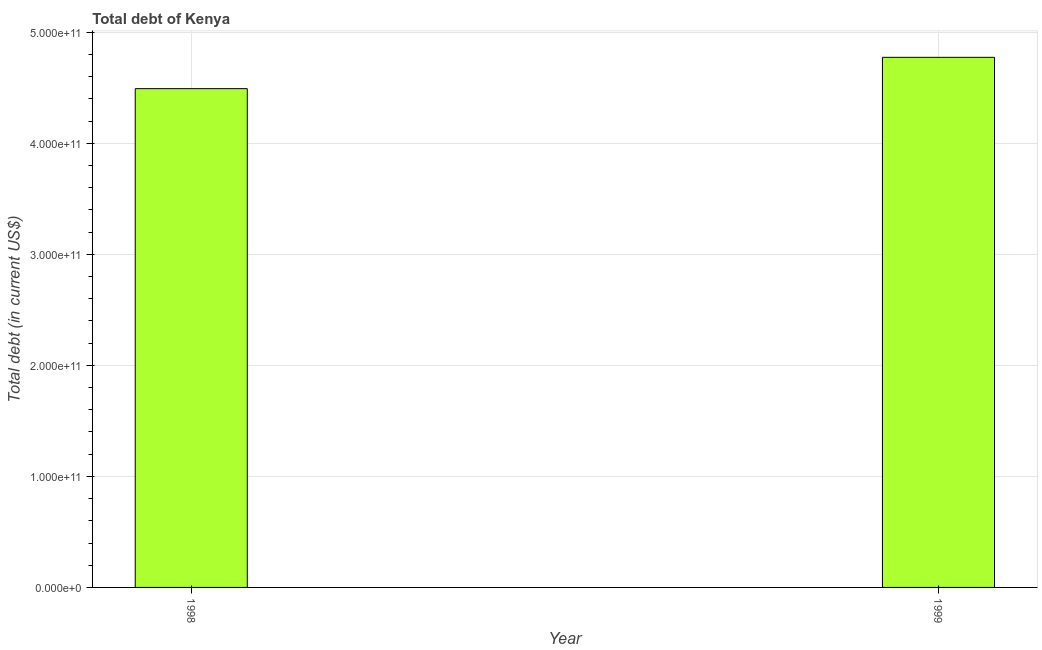Does the graph contain any zero values?
Your answer should be compact. No. Does the graph contain grids?
Make the answer very short. Yes. What is the title of the graph?
Offer a terse response. Total debt of Kenya. What is the label or title of the X-axis?
Keep it short and to the point. Year. What is the label or title of the Y-axis?
Provide a short and direct response. Total debt (in current US$). What is the total debt in 1998?
Offer a very short reply. 4.49e+11. Across all years, what is the maximum total debt?
Offer a terse response. 4.77e+11. Across all years, what is the minimum total debt?
Offer a terse response. 4.49e+11. In which year was the total debt minimum?
Make the answer very short. 1998. What is the sum of the total debt?
Offer a very short reply. 9.27e+11. What is the difference between the total debt in 1998 and 1999?
Your response must be concise. -2.82e+1. What is the average total debt per year?
Ensure brevity in your answer.  4.63e+11. What is the median total debt?
Offer a very short reply. 4.63e+11. What is the ratio of the total debt in 1998 to that in 1999?
Offer a terse response. 0.94. Are all the bars in the graph horizontal?
Offer a terse response. No. How many years are there in the graph?
Offer a very short reply. 2. What is the difference between two consecutive major ticks on the Y-axis?
Your response must be concise. 1.00e+11. Are the values on the major ticks of Y-axis written in scientific E-notation?
Offer a very short reply. Yes. What is the Total debt (in current US$) of 1998?
Ensure brevity in your answer.  4.49e+11. What is the Total debt (in current US$) in 1999?
Keep it short and to the point. 4.77e+11. What is the difference between the Total debt (in current US$) in 1998 and 1999?
Keep it short and to the point. -2.82e+1. What is the ratio of the Total debt (in current US$) in 1998 to that in 1999?
Your answer should be compact. 0.94. 